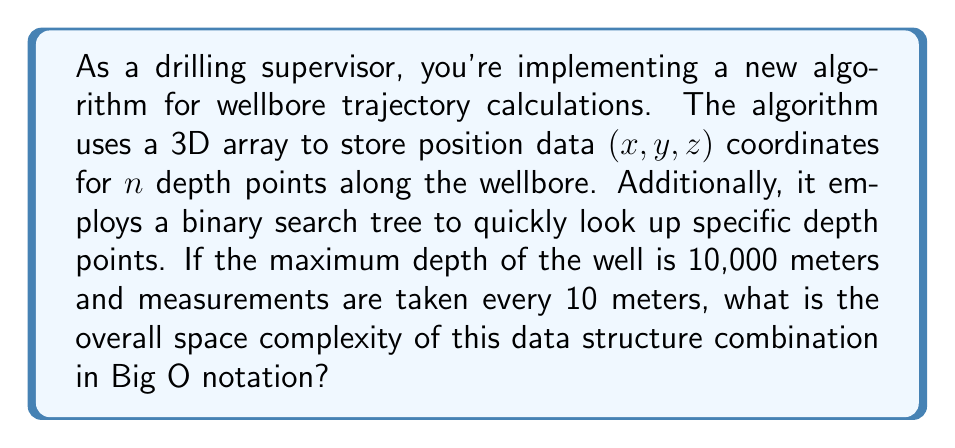Can you solve this math problem? To determine the space complexity, let's analyze each data structure separately:

1. 3D Array:
   - The number of depth points, n = 10,000 m / 10 m = 1,000
   - Each depth point stores 3 coordinates (x, y, z)
   - Space required: $O(n)$ = $O(1000)$ = $O(n)$

2. Binary Search Tree (BST):
   - The BST will contain n nodes, one for each depth point
   - Each node typically contains a value and two pointers (left and right child)
   - In the worst case (unbalanced tree), the space complexity is $O(n)$
   - In the average case (balanced tree), it's still $O(n)$

The overall space complexity is the sum of the space required by both data structures:

$$O(n) + O(n) = O(n)$$

The constant factors and lower-order terms are dropped in Big O notation, so the final space complexity remains $O(n)$.

It's worth noting that while the 3D array has a fixed size based on the well depth, the BST's space usage might vary slightly depending on the tree's balance. However, this doesn't affect the overall Big O complexity.
Answer: $O(n)$, where n is the number of depth points along the wellbore. 